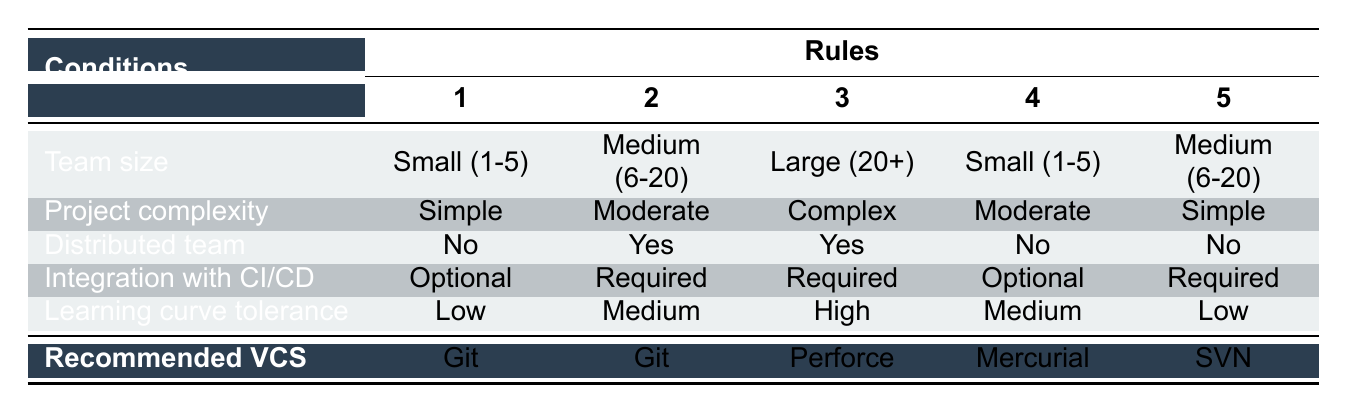What VCS is recommended for a medium-sized team working on a complex project that requires CI/CD integration? According to the table, for a medium-sized team (6-20) with complex projects that require integration with CI/CD, the recommended version control system is Mercurial.
Answer: Mercurial Is Git recommended for a small team with simple project requirements? The table indicates that for a small team (1-5) working on a simple project, the recommended VCS is Git, as per rule 1.
Answer: Yes What VCS is recommended for a large team working on a complex project with a distributed team? The rules indicate that for a large team (20+) working on a complex project and is also a distributed team, the recommended VCS is Perforce.
Answer: Perforce How many rules recommend using Git for teams of different sizes? By analyzing the table, there are four rules that recommend Git: 1) Small team, simple project, no distribution, optional CI/CD; 2) Medium team, moderate project, required CI/CD; 3) Large team, complex project, no distribution, required CI/CD; 4) Small team, complex project, distributed, required CI/CD. Thus, the total is four rules recommending Git.
Answer: Four Is SVN recommended for a small team with a low tolerance for learning curve? The table shows that SVN is not recommended for a small team with a low tolerance for the learning curve, as it is specifically recommended for medium teams with simple projects that require CI/CD integration.
Answer: No What is the recommended VCS for a large team with moderate project complexity and optional CI/CD? The table indicates that there is no rule for a large team with moderate complexity and optional CI/CD; therefore, none is recommended for that specific scenario. The closest covered scenario would be for complex projects which does not fit here.
Answer: None Does a medium-sized team working on a simple project with a distributed setup have a specific VCS recommendation? The table confirms that for a medium-sized team (6-20) with a simple project and distributed setup, there is no specific recommendation made by the rules, suggesting that other teams should follow different guidelines or rules.
Answer: No Which VCS would be recommended if learning curve tolerance is high and the project is complex? For a team with high learning curve tolerance working on a complex project, the table shows a recommendation for Perforce if the team size is large and the setup is distributed while Git is recommended for a small team if CI/CD is required. Therefore, two possible recommendations might exist based on team size.
Answer: Perforce or Git 